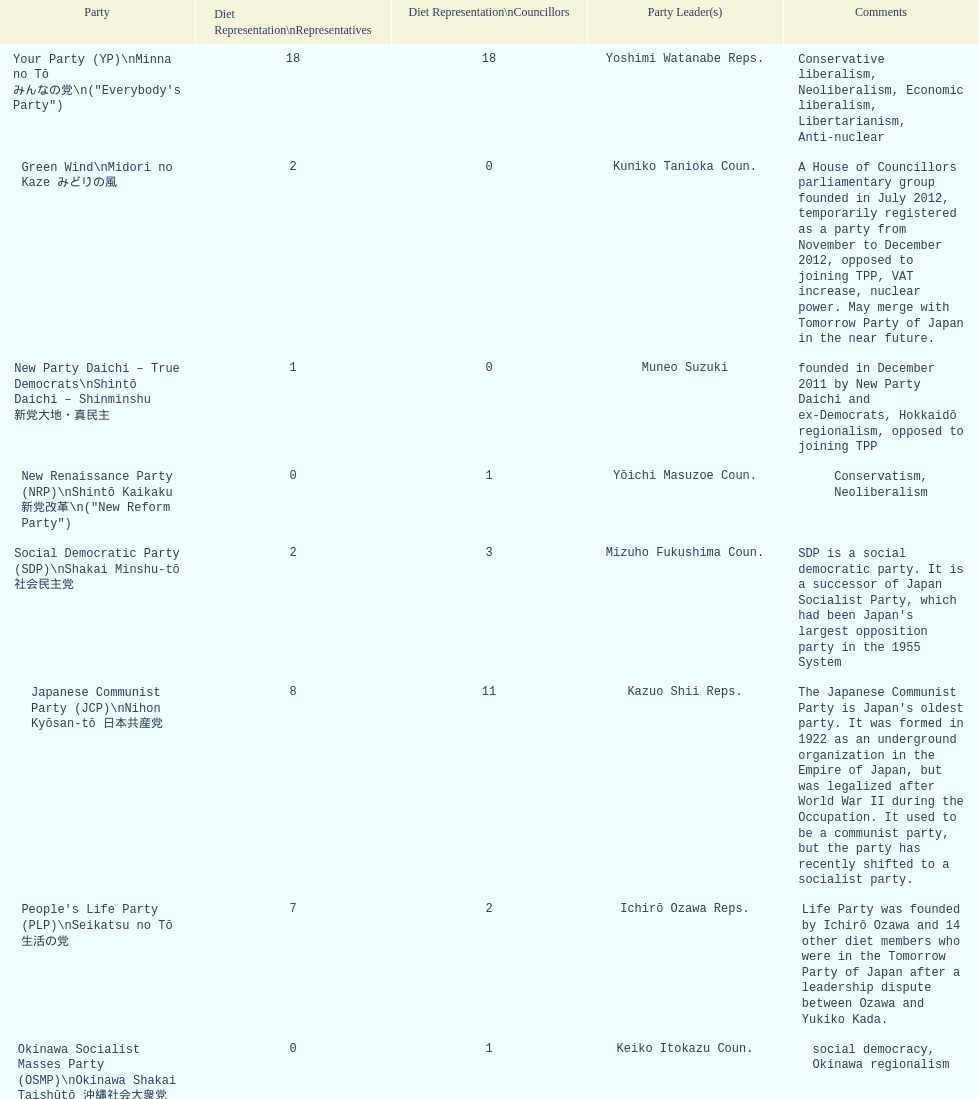How many representatives come from the green wind party? 2. 